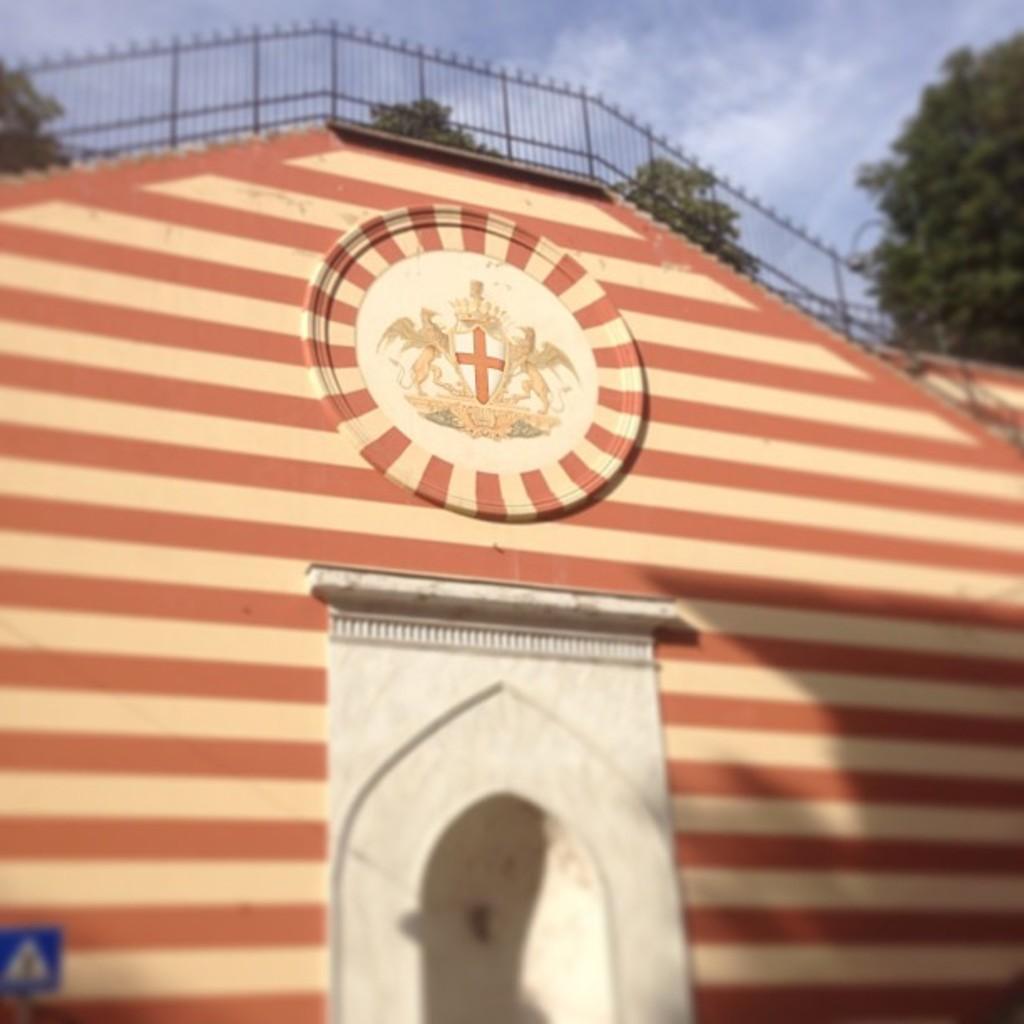How would you summarize this image in a sentence or two? In the picture we can see a building wall on it, we can see horizontal lines of brown and cream color lines and some cross symbol on it and on the top of the wall we can see railing and behind it we can see some trees and sky with clouds. 